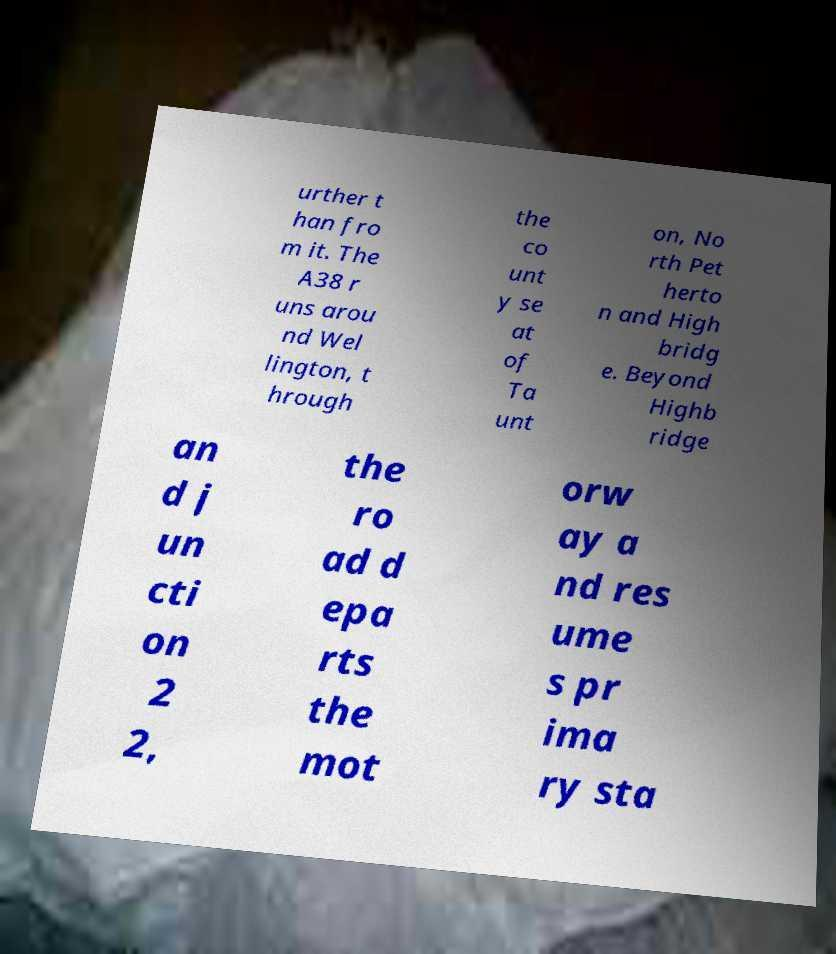For documentation purposes, I need the text within this image transcribed. Could you provide that? urther t han fro m it. The A38 r uns arou nd Wel lington, t hrough the co unt y se at of Ta unt on, No rth Pet herto n and High bridg e. Beyond Highb ridge an d j un cti on 2 2, the ro ad d epa rts the mot orw ay a nd res ume s pr ima ry sta 